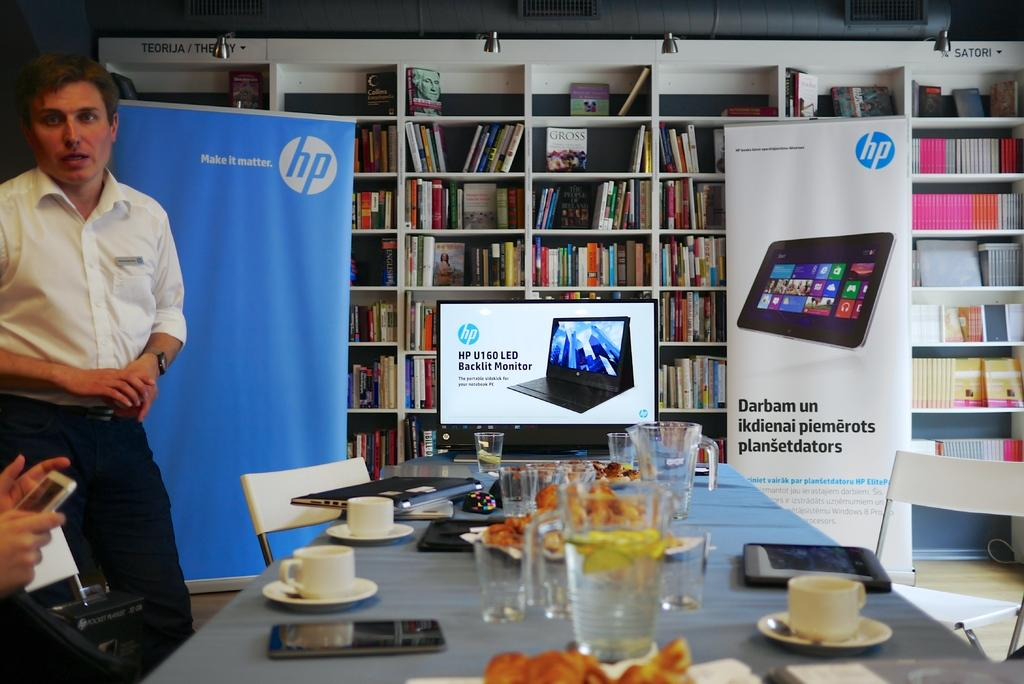<image>
Relay a brief, clear account of the picture shown. Man making a presentation in front of others about HP products. 